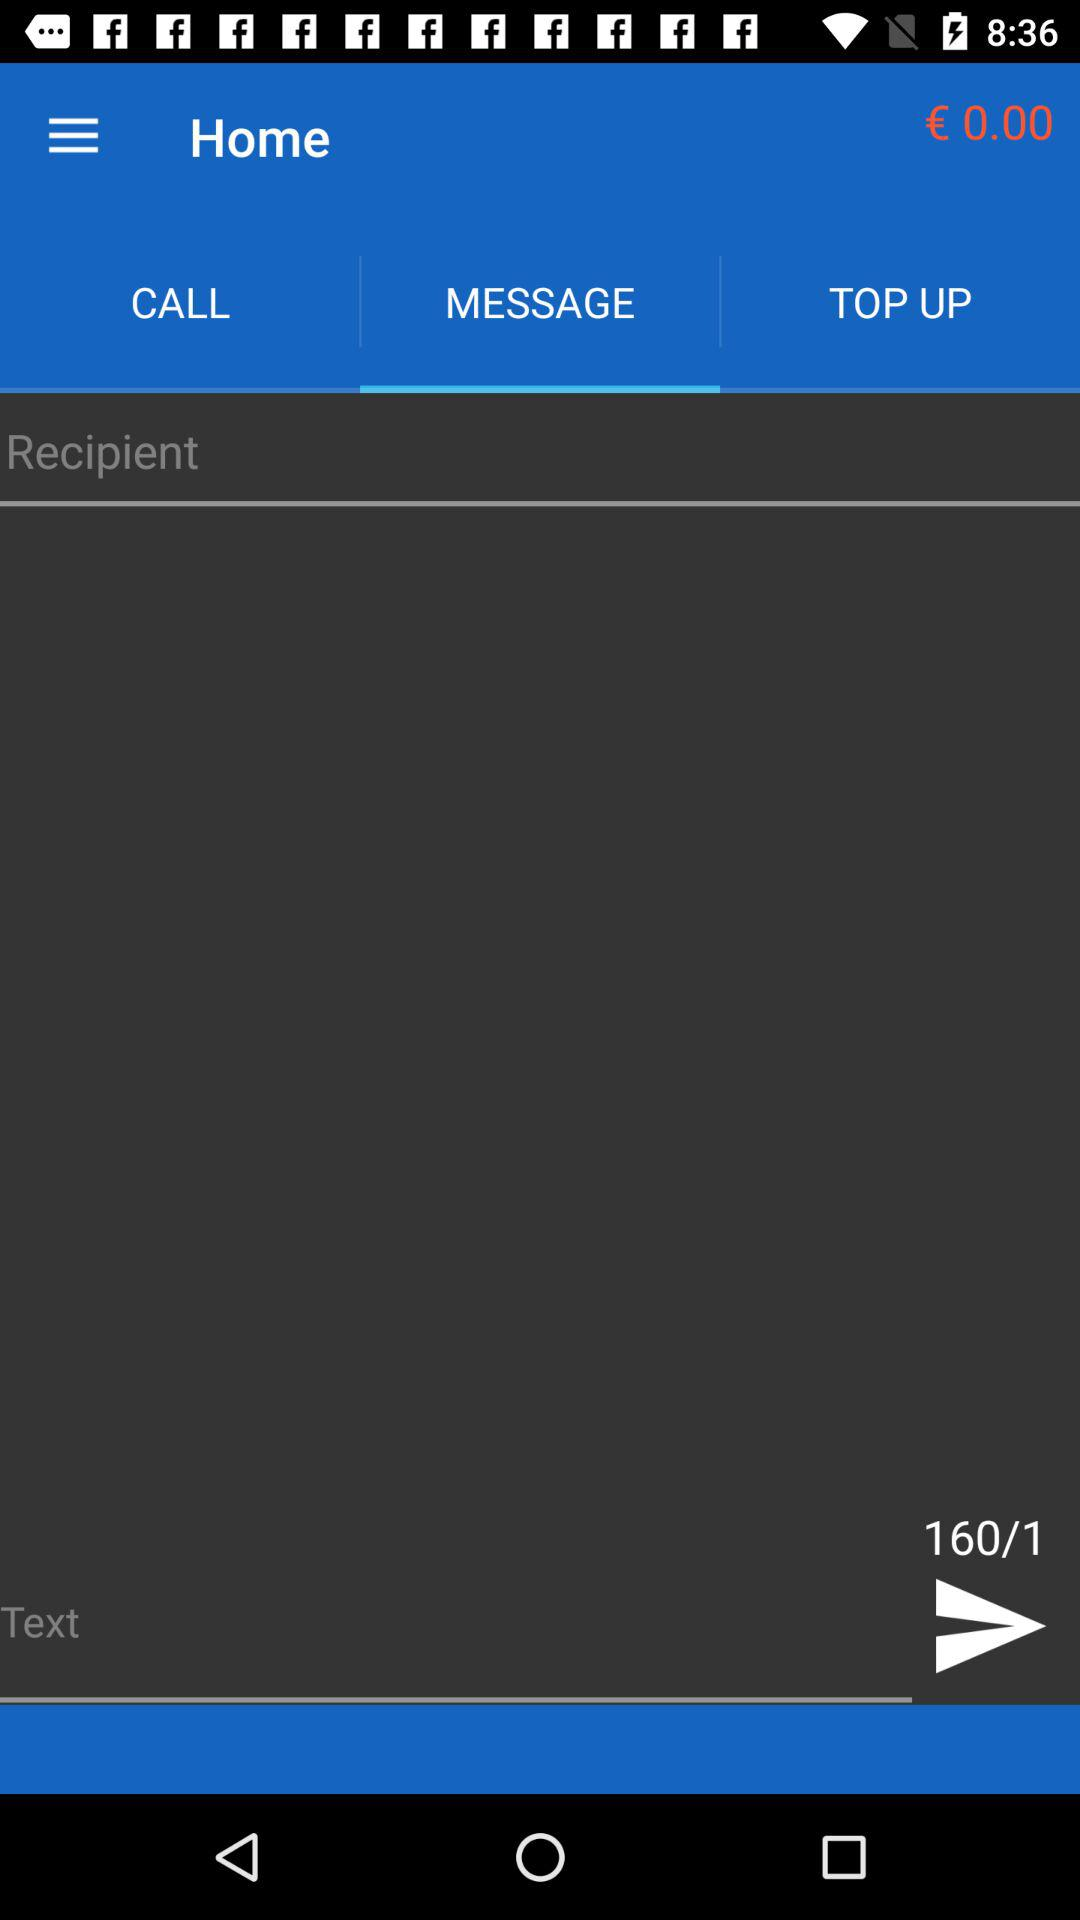What is the maximum number of words for text? The maximum number of words for text is 160. 